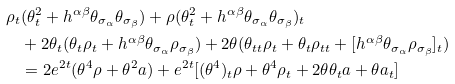Convert formula to latex. <formula><loc_0><loc_0><loc_500><loc_500>\rho _ { t } & ( \theta _ { t } ^ { 2 } + h ^ { \alpha \beta } \theta _ { \sigma _ { \alpha } } \theta _ { \sigma _ { \beta } } ) + \rho ( \theta _ { t } ^ { 2 } + h ^ { \alpha \beta } \theta _ { \sigma _ { \alpha } } \theta _ { \sigma _ { \beta } } ) _ { t } \\ & + 2 \theta _ { t } ( \theta _ { t } \rho _ { t } + h ^ { \alpha \beta } \theta _ { \sigma _ { \alpha } } \rho _ { \sigma _ { \beta } } ) + 2 \theta ( \theta _ { t t } \rho _ { t } + \theta _ { t } \rho _ { t t } + [ h ^ { \alpha \beta } \theta _ { \sigma _ { \alpha } } \rho _ { \sigma _ { \beta } } ] _ { t } ) \\ & = 2 e ^ { 2 t } ( \theta ^ { 4 } \rho + \theta ^ { 2 } a ) + e ^ { 2 t } [ ( \theta ^ { 4 } ) _ { t } \rho + \theta ^ { 4 } \rho _ { t } + 2 \theta \theta _ { t } a + \theta a _ { t } ]</formula> 